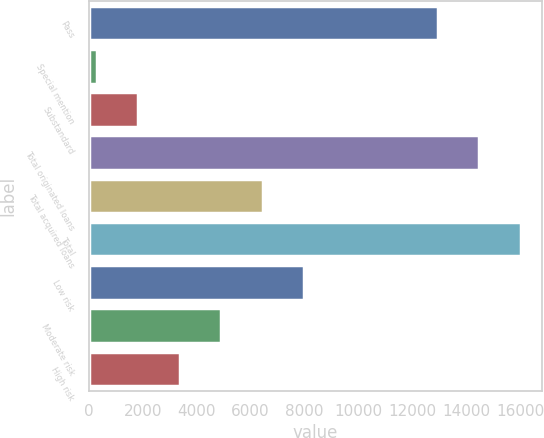Convert chart. <chart><loc_0><loc_0><loc_500><loc_500><bar_chart><fcel>Pass<fcel>Special mention<fcel>Substandard<fcel>Total originated loans<fcel>Total acquired loans<fcel>Total<fcel>Low risk<fcel>Moderate risk<fcel>High risk<nl><fcel>12929.3<fcel>289.2<fcel>1829.7<fcel>14469.8<fcel>6451.2<fcel>16010.3<fcel>7991.7<fcel>4910.7<fcel>3370.2<nl></chart> 